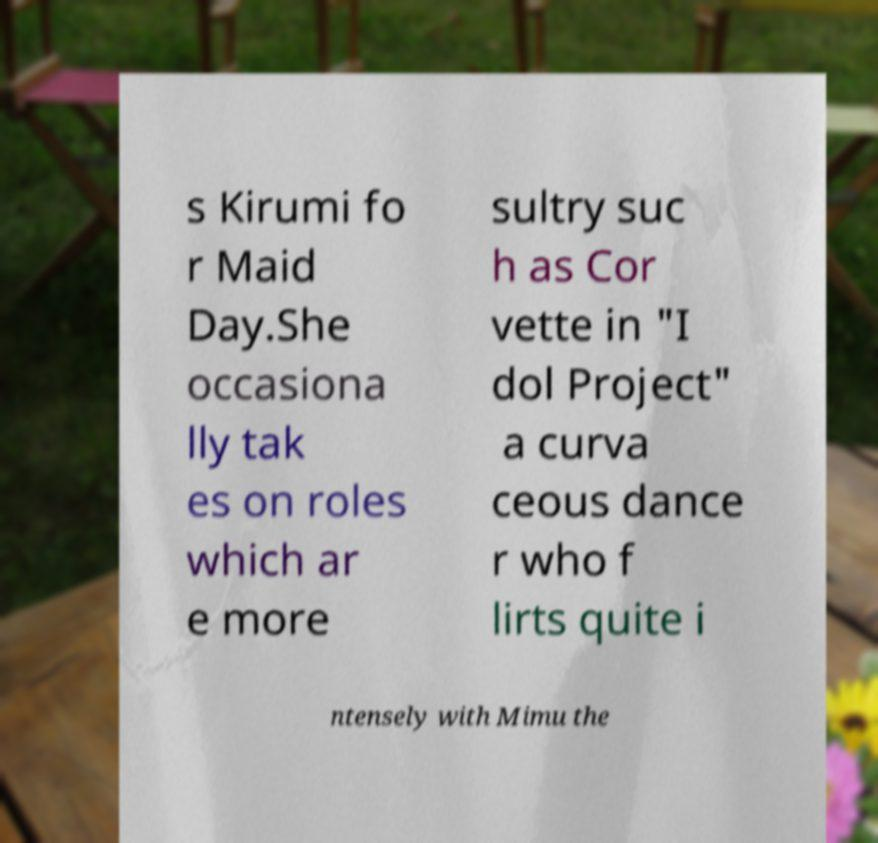Can you accurately transcribe the text from the provided image for me? s Kirumi fo r Maid Day.She occasiona lly tak es on roles which ar e more sultry suc h as Cor vette in "I dol Project" a curva ceous dance r who f lirts quite i ntensely with Mimu the 